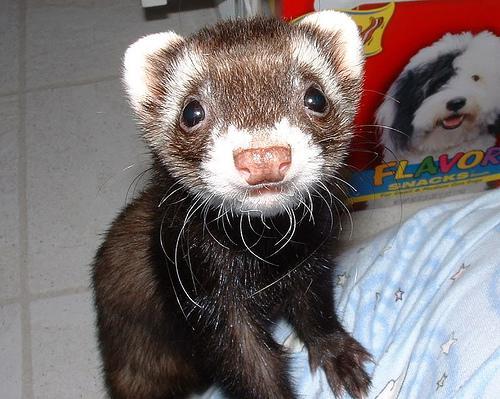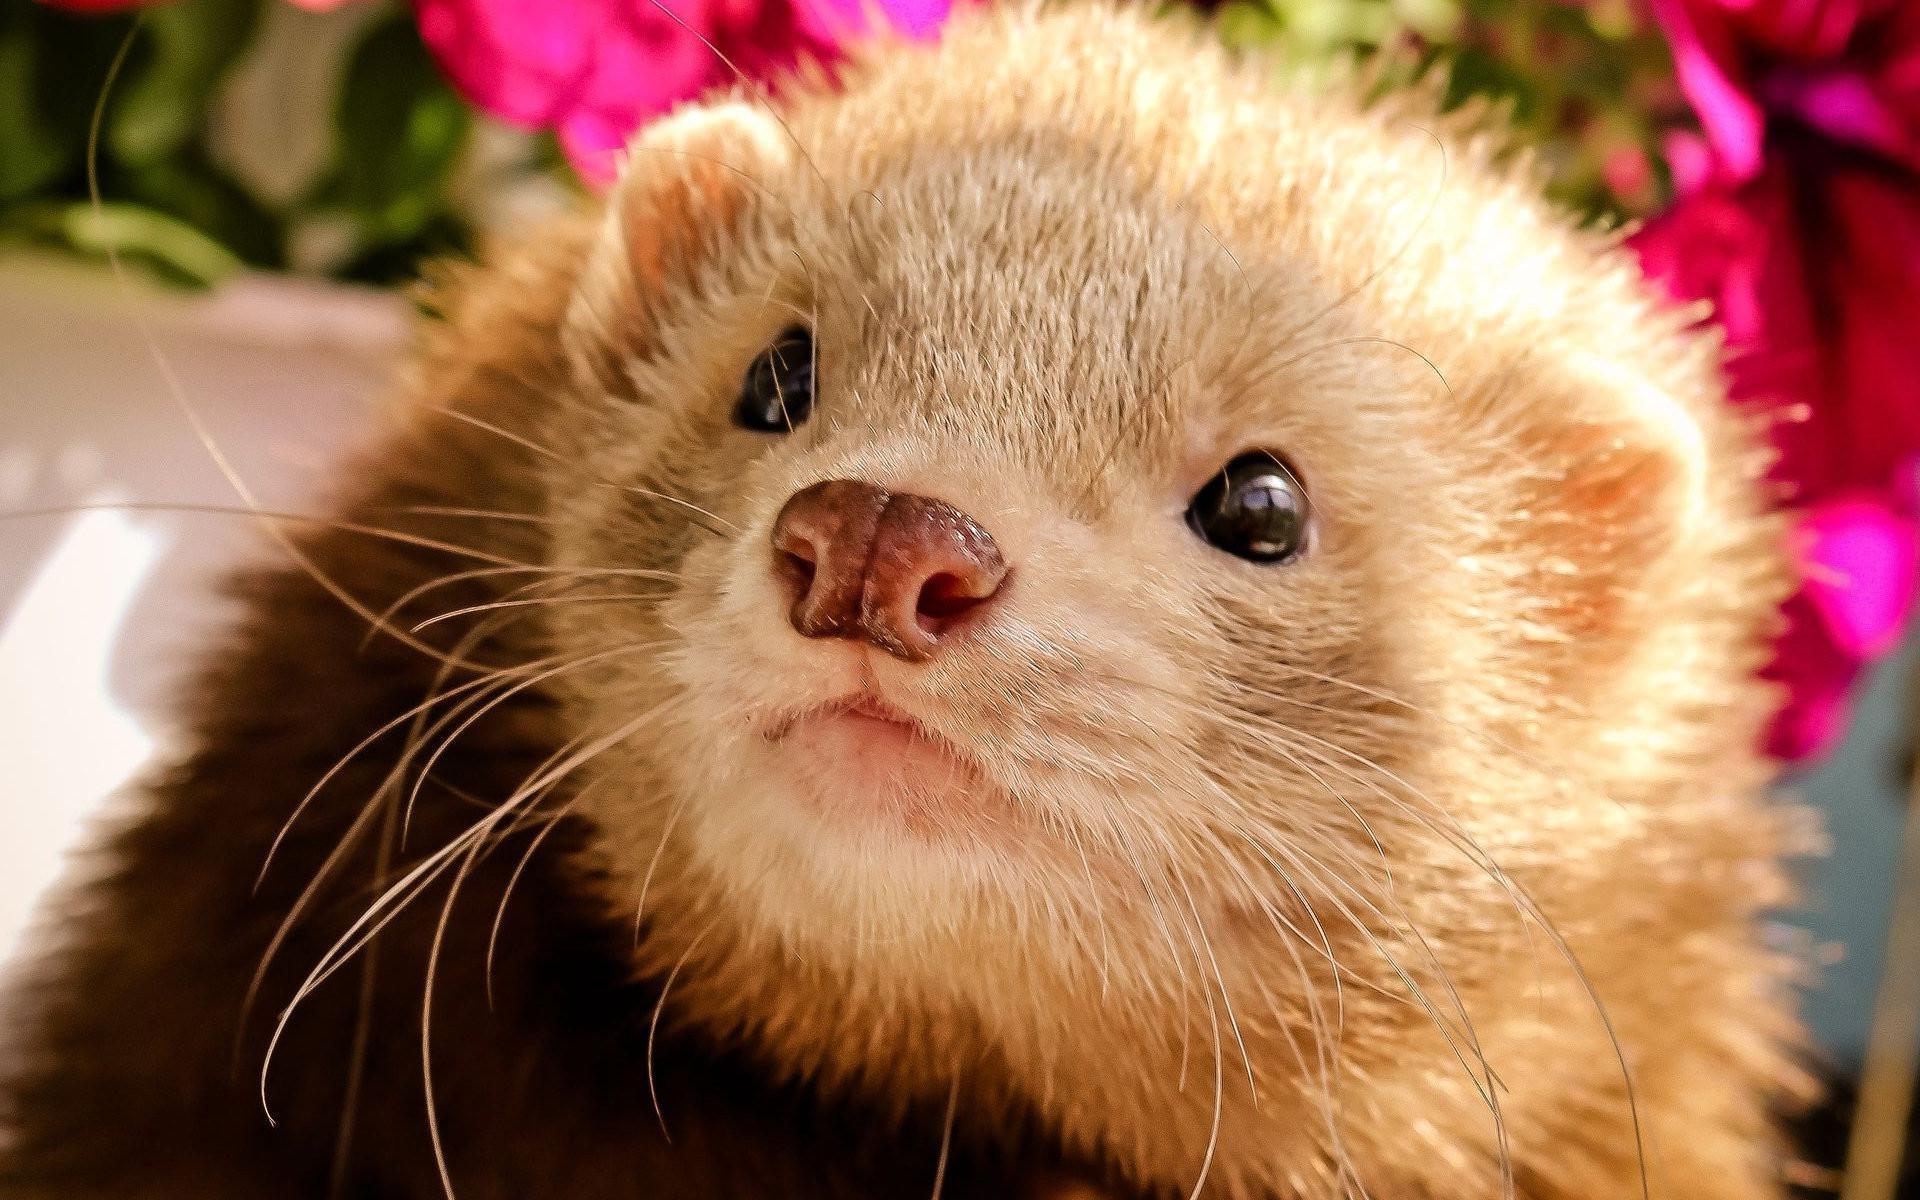The first image is the image on the left, the second image is the image on the right. Examine the images to the left and right. Is the description "In one of the images there is one animal being held." accurate? Answer yes or no. No. The first image is the image on the left, the second image is the image on the right. Evaluate the accuracy of this statement regarding the images: "The combined images contain four ferrets, at least three ferrets have raccoon-mask markings, and a human hand is grasping at least one ferret.". Is it true? Answer yes or no. No. 